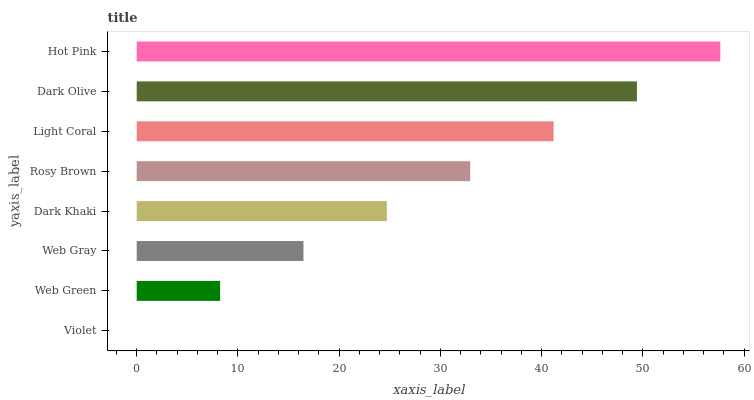Is Violet the minimum?
Answer yes or no. Yes. Is Hot Pink the maximum?
Answer yes or no. Yes. Is Web Green the minimum?
Answer yes or no. No. Is Web Green the maximum?
Answer yes or no. No. Is Web Green greater than Violet?
Answer yes or no. Yes. Is Violet less than Web Green?
Answer yes or no. Yes. Is Violet greater than Web Green?
Answer yes or no. No. Is Web Green less than Violet?
Answer yes or no. No. Is Rosy Brown the high median?
Answer yes or no. Yes. Is Dark Khaki the low median?
Answer yes or no. Yes. Is Web Gray the high median?
Answer yes or no. No. Is Web Green the low median?
Answer yes or no. No. 